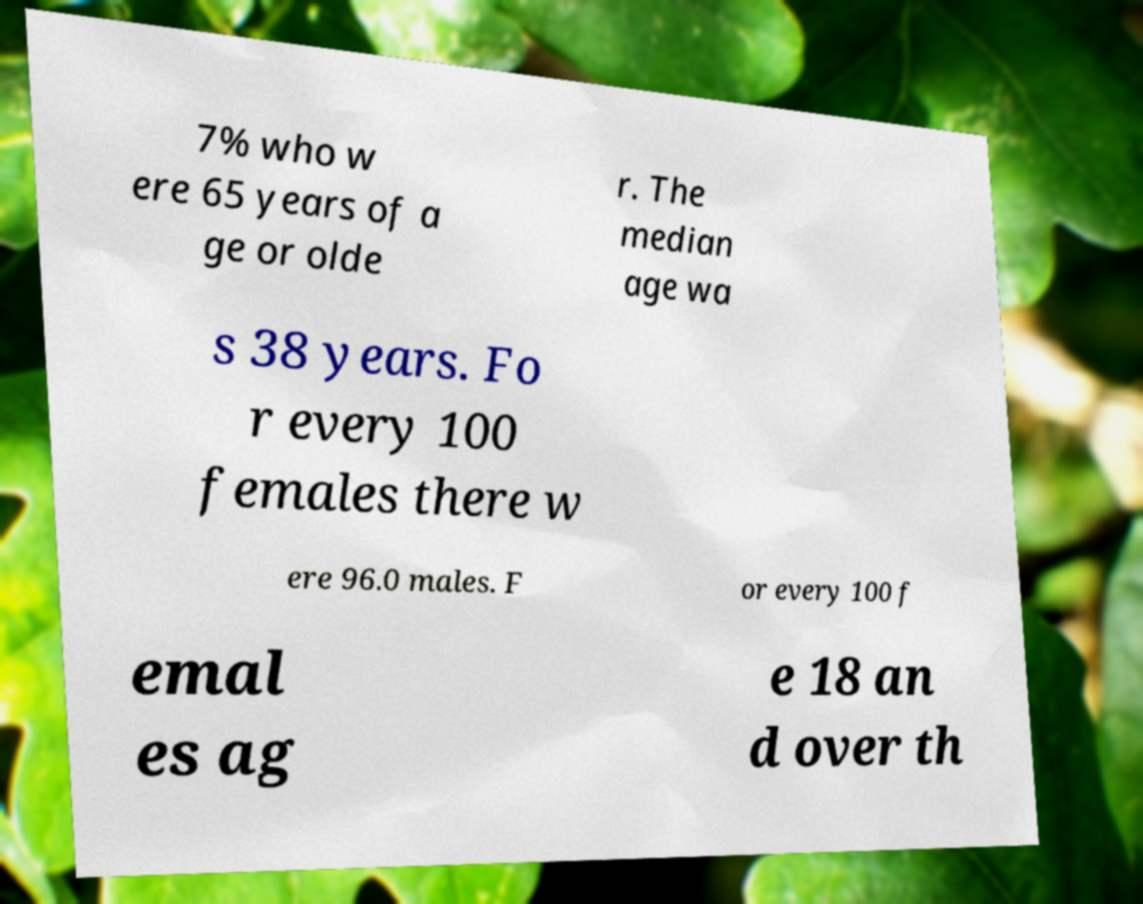Please identify and transcribe the text found in this image. 7% who w ere 65 years of a ge or olde r. The median age wa s 38 years. Fo r every 100 females there w ere 96.0 males. F or every 100 f emal es ag e 18 an d over th 